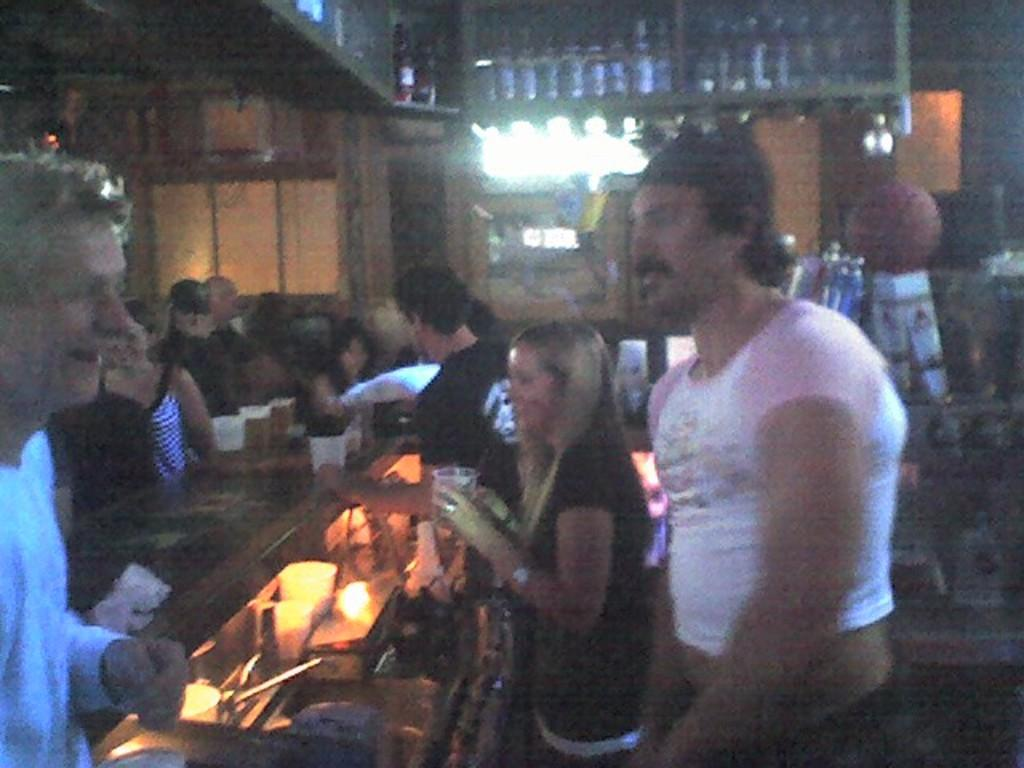Who is the main subject in the image? There is a lady in the image. What is the lady holding in her hands? The lady is holding a glass in her hands. How many people can be seen in the image? There are many people in the image. Where are additional glasses located in the image? There are glasses placed on a table in the image. What can be seen on the shelf at the top of the image? There are bottles on a shelf at the top of the image. Can you tell me how many thumbs the lady has on her left hand in the image? The number of thumbs the lady has cannot be determined from the image, as it does not show her hands in detail. 